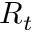<formula> <loc_0><loc_0><loc_500><loc_500>R _ { t }</formula> 